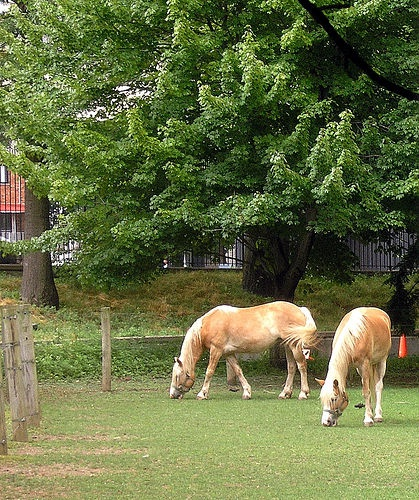Describe the objects in this image and their specific colors. I can see horse in gray, tan, and beige tones and horse in gray, ivory, and tan tones in this image. 